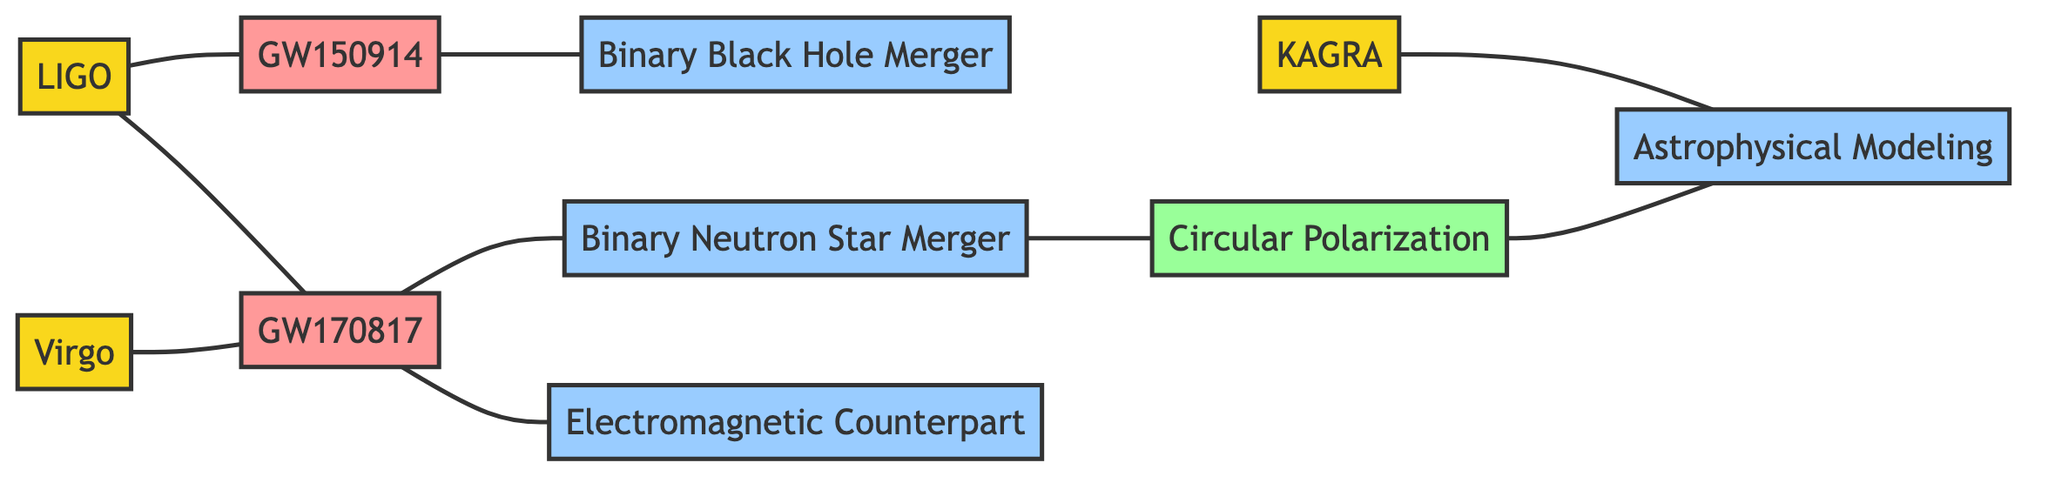What is the total number of nodes in the diagram? The diagram contains 10 nodes representing various gravitational wave observatories, cosmic events, and phenomena. By counting all the unique entries in the nodes section of the data, we confirm there are 10 nodes.
Answer: 10 Which observatories are connected to the event GW170817? In the diagram, the observatories LIGO and Virgo are connected to the event GW170817. This is shown by the edges connecting these nodes in the graph.
Answer: LIGO, Virgo What event is connected to the Binary Black Hole Merger? The event GW150914 is connected to the Binary Black Hole Merger in the diagram. The edge from GW150914 to Binary Black Hole indicates this direct connection.
Answer: GW150914 How many edges are there in the diagram? The diagram has 8 edges. This represents the connections between the nodes. By counting each pair of connected nodes (edges) in the edges section, we find there are 8 edges total.
Answer: 8 What type of phenomenon is associated with the Neutron Star Merger? The phenomenon directly associated with the Neutron Star Merger is Circular Polarization, as indicated by the edge connecting these two nodes.
Answer: Circular Polarization Which observatory is connected to Astrophysical Modeling? The observatory KAGRA is connected to Astrophysical Modeling, as demonstrated by the edge linking the KAGRA node to the Astrophysical Modeling node.
Answer: KAGRA What are the primary connections for the event GW150914 in this diagram? The event GW150914 has a direct connection to LIGO and the Binary Black Hole Merger. This is seen in the edges that link GW150914 to both the LIGO observatory and the Binary Black Hole phenomenon.
Answer: LIGO, Binary Black Hole Which event acts as a precursor to both the Neutron Star Merger and the Electromagnetic Counterpart? The event GW170817 serves as a precursor to both the Neutron Star Merger and the Electromagnetic Counterpart, as it has edges connecting to both of these nodes.
Answer: GW170817 